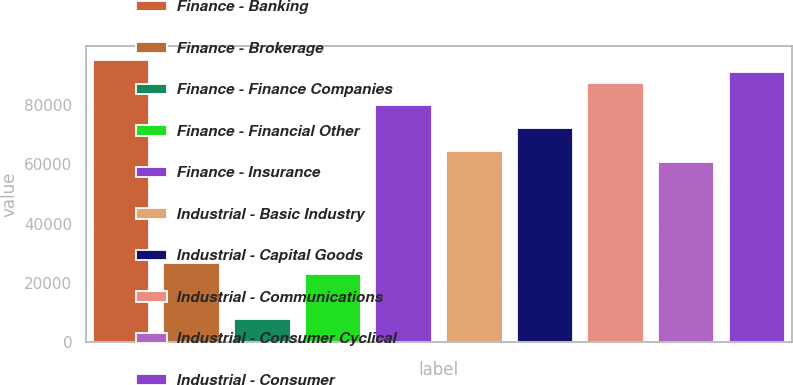<chart> <loc_0><loc_0><loc_500><loc_500><bar_chart><fcel>Finance - Banking<fcel>Finance - Brokerage<fcel>Finance - Finance Companies<fcel>Finance - Financial Other<fcel>Finance - Insurance<fcel>Industrial - Basic Industry<fcel>Industrial - Capital Goods<fcel>Industrial - Communications<fcel>Industrial - Consumer Cyclical<fcel>Industrial - Consumer<nl><fcel>95115.7<fcel>26666<fcel>7652.22<fcel>22863.3<fcel>79904.7<fcel>64693.6<fcel>72299.1<fcel>87510.2<fcel>60890.9<fcel>91312.9<nl></chart> 